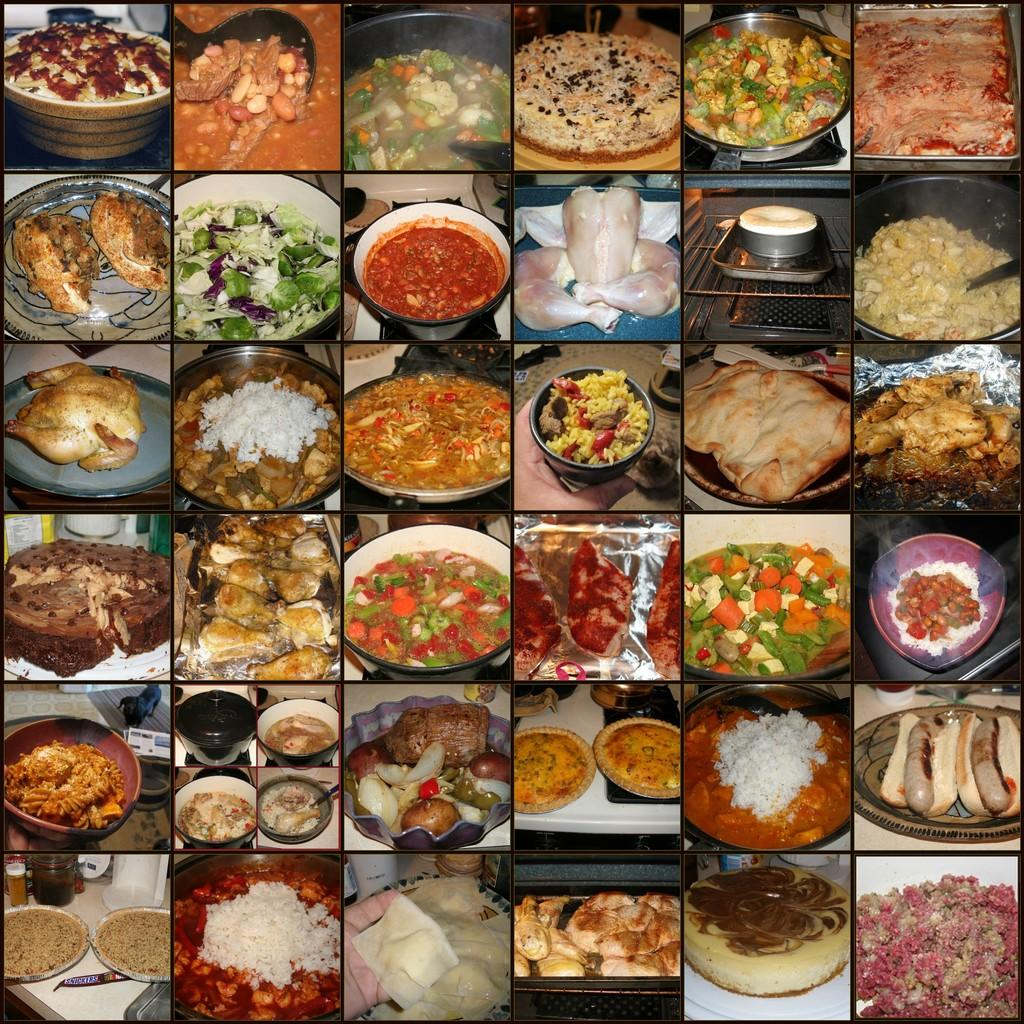What is present in the image that contains food? There are different types of dishes in the image, and they are in bowls. Can you describe the dishes in the bowls? Unfortunately, the specific types of dishes cannot be determined from the provided facts. What type of linen can be seen draped over the dishes in the image? There is no linen, or any fabric present in the image. What subject is being taught in the image? There is no teaching or educational activity depicted in the image. 